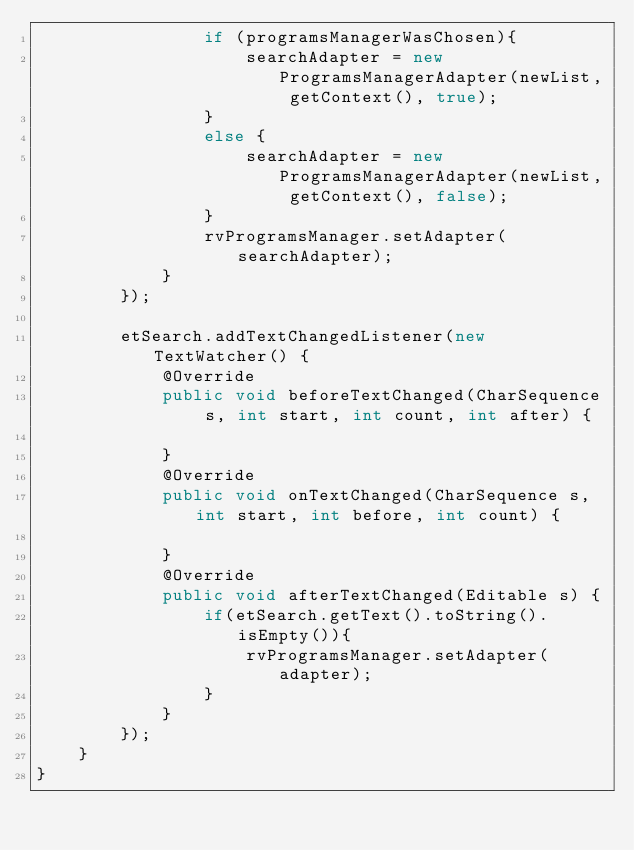<code> <loc_0><loc_0><loc_500><loc_500><_Java_>                if (programsManagerWasChosen){
                    searchAdapter = new ProgramsManagerAdapter(newList, getContext(), true);
                }
                else {
                    searchAdapter = new ProgramsManagerAdapter(newList, getContext(), false);
                }
                rvProgramsManager.setAdapter(searchAdapter);
            }
        });

        etSearch.addTextChangedListener(new TextWatcher() {
            @Override
            public void beforeTextChanged(CharSequence s, int start, int count, int after) {

            }
            @Override
            public void onTextChanged(CharSequence s, int start, int before, int count) {

            }
            @Override
            public void afterTextChanged(Editable s) {
                if(etSearch.getText().toString().isEmpty()){
                    rvProgramsManager.setAdapter(adapter);
                }
            }
        });
    }
}
</code> 